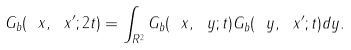<formula> <loc_0><loc_0><loc_500><loc_500>G _ { b } ( \ x , \ x ^ { \prime } ; 2 t ) = \int _ { { R } ^ { 2 } } G _ { b } ( \ x , \ y ; t ) G _ { b } ( \ y , \ x ^ { \prime } ; t ) d { y } .</formula> 